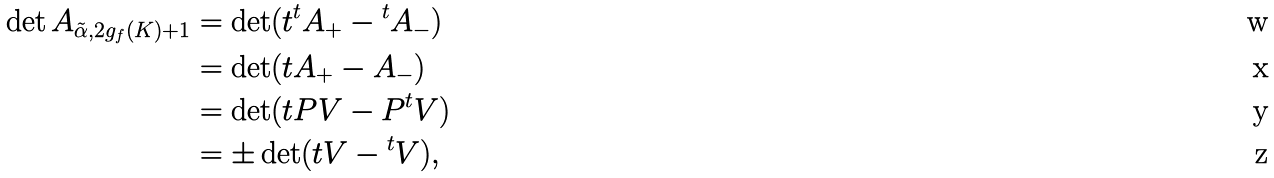Convert formula to latex. <formula><loc_0><loc_0><loc_500><loc_500>\det A _ { \tilde { \alpha } , 2 g _ { f } ( K ) + 1 } & = \det ( t { ^ { t } A _ { + } } - { ^ { t } A _ { - } } ) \\ & = \det ( t A _ { + } - A _ { - } ) \\ & = \det ( t P V - P { ^ { t } V } ) \\ & = \pm \det ( t V - { ^ { t } V } ) ,</formula> 